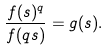<formula> <loc_0><loc_0><loc_500><loc_500>\frac { f ( s ) ^ { q } } { f ( q s ) } = g ( s ) .</formula> 